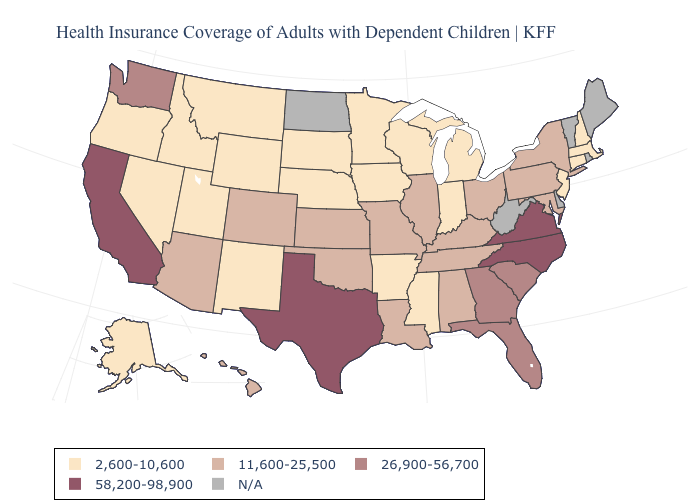Does the map have missing data?
Keep it brief. Yes. What is the value of West Virginia?
Write a very short answer. N/A. Name the states that have a value in the range 2,600-10,600?
Be succinct. Alaska, Arkansas, Connecticut, Idaho, Indiana, Iowa, Massachusetts, Michigan, Minnesota, Mississippi, Montana, Nebraska, Nevada, New Hampshire, New Jersey, New Mexico, Oregon, South Dakota, Utah, Wisconsin, Wyoming. Which states have the highest value in the USA?
Quick response, please. California, North Carolina, Texas, Virginia. Name the states that have a value in the range 2,600-10,600?
Concise answer only. Alaska, Arkansas, Connecticut, Idaho, Indiana, Iowa, Massachusetts, Michigan, Minnesota, Mississippi, Montana, Nebraska, Nevada, New Hampshire, New Jersey, New Mexico, Oregon, South Dakota, Utah, Wisconsin, Wyoming. Does North Carolina have the highest value in the USA?
Short answer required. Yes. Does Missouri have the lowest value in the MidWest?
Write a very short answer. No. What is the value of Wyoming?
Write a very short answer. 2,600-10,600. What is the value of Tennessee?
Concise answer only. 11,600-25,500. Does the map have missing data?
Write a very short answer. Yes. Is the legend a continuous bar?
Quick response, please. No. Does the map have missing data?
Quick response, please. Yes. What is the highest value in the West ?
Quick response, please. 58,200-98,900. What is the value of Connecticut?
Give a very brief answer. 2,600-10,600. 